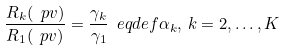<formula> <loc_0><loc_0><loc_500><loc_500>\frac { R _ { k } ( \ p v ) } { R _ { 1 } ( \ p v ) } = \frac { \gamma _ { k } } { \gamma _ { 1 } } \ e q d e f \alpha _ { k } , \, k = 2 , \dots , K</formula> 